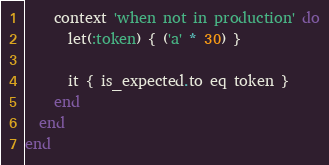<code> <loc_0><loc_0><loc_500><loc_500><_Ruby_>
    context 'when not in production' do
      let(:token) { ('a' * 30) }

      it { is_expected.to eq token }
    end
  end
end
</code> 